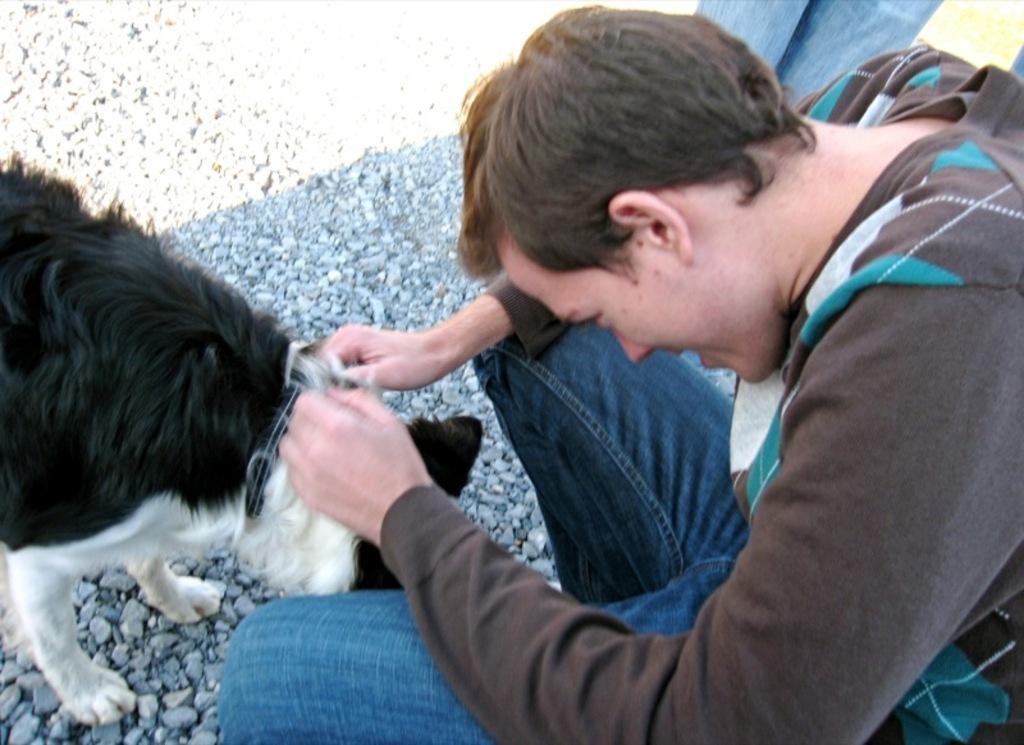Can you describe this image briefly? In this image I can see a person holding the animal. 